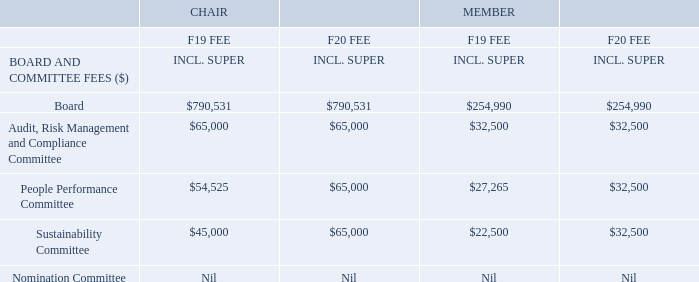Non‐executive Director fees are paid from an aggregate annual fee pool of $4,000,000, as approved by shareholders at the AGM on 18 November 2010. Total board and committee fees paid during F19 were $2,859,903 (refer to section 5.1).
Non‐executive Directors do not receive variable pay and no Directors’ fees are paid to Executive Directors.
In recognition of the equal importance and workload of all of the Board’s Committees, the Board reviewed Non‐executive Director fees and determined to increase Chair and Member fees for the People Performance Committee and Sustainability Committee as detailed in the table below, effective 1 July 2019. The table below provides a summary of F19 and F20 Board and Committee fees:
What was the total board and committee fees paid during F19? $2,859,903. What is the F19 fee for a member of the People Performance Committee? $27,265. What is the value of the aggregate annual fee pool used to pay non-executive Director fees? $4,000,000. What is the percentage increase for the fees paid to the Chair of Sustainability Committee between F19 and F20?
Answer scale should be: percent. (65,000 - 45,000)/ 45,000 
Answer: 44.44. What is the nominal difference for the fees paid in F19 and F20 to a member in the board? 254,990 - 254,990 
Answer: 0. What is the difference between the fees paid to a member in the board compared to a member in the sustainability committee in F19? 254,990 - 22,500 
Answer: 232490. 